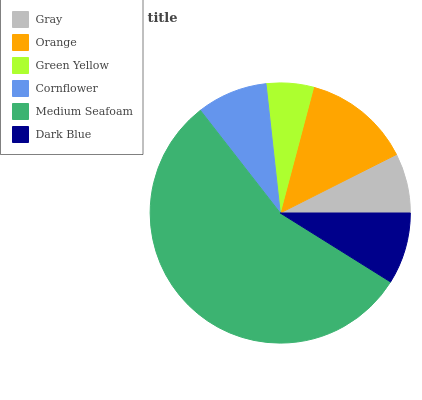Is Green Yellow the minimum?
Answer yes or no. Yes. Is Medium Seafoam the maximum?
Answer yes or no. Yes. Is Orange the minimum?
Answer yes or no. No. Is Orange the maximum?
Answer yes or no. No. Is Orange greater than Gray?
Answer yes or no. Yes. Is Gray less than Orange?
Answer yes or no. Yes. Is Gray greater than Orange?
Answer yes or no. No. Is Orange less than Gray?
Answer yes or no. No. Is Dark Blue the high median?
Answer yes or no. Yes. Is Cornflower the low median?
Answer yes or no. Yes. Is Medium Seafoam the high median?
Answer yes or no. No. Is Gray the low median?
Answer yes or no. No. 